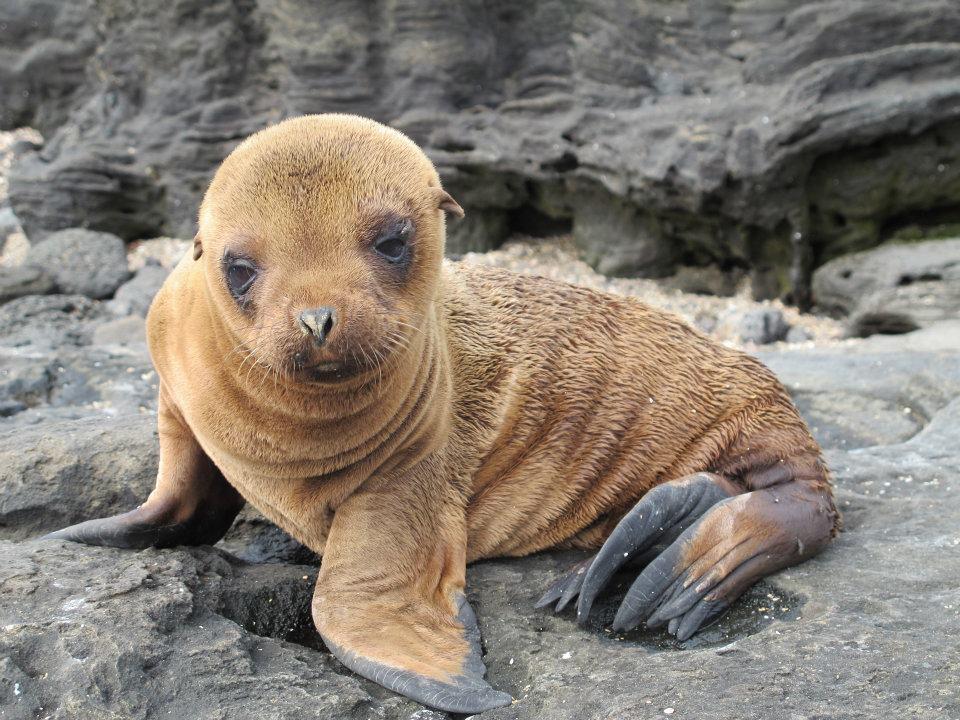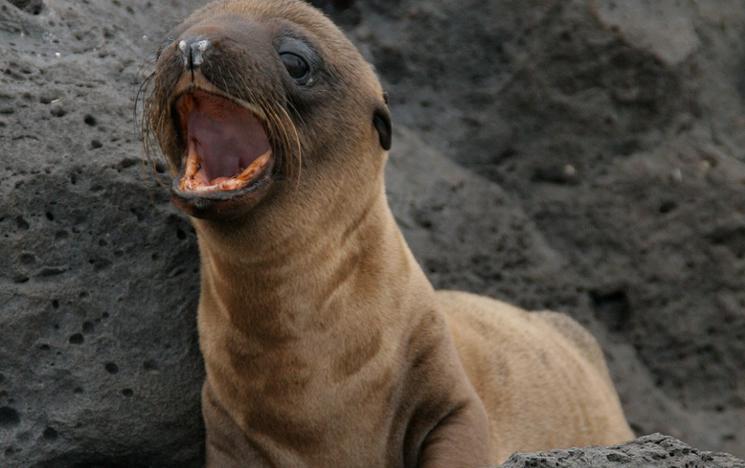The first image is the image on the left, the second image is the image on the right. Assess this claim about the two images: "Right image features one close-mouthed brown baby seal starting into the camera.". Correct or not? Answer yes or no. No. 